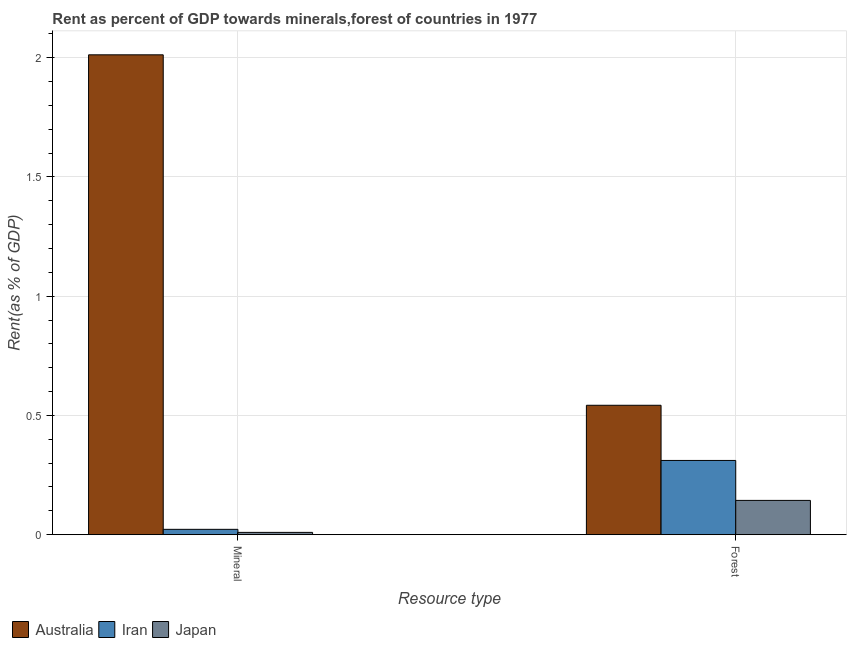How many different coloured bars are there?
Your answer should be very brief. 3. How many groups of bars are there?
Your answer should be compact. 2. Are the number of bars per tick equal to the number of legend labels?
Your answer should be very brief. Yes. How many bars are there on the 1st tick from the right?
Your answer should be compact. 3. What is the label of the 2nd group of bars from the left?
Ensure brevity in your answer.  Forest. What is the mineral rent in Japan?
Your response must be concise. 0.01. Across all countries, what is the maximum forest rent?
Offer a very short reply. 0.54. Across all countries, what is the minimum forest rent?
Provide a short and direct response. 0.14. In which country was the mineral rent maximum?
Make the answer very short. Australia. What is the total mineral rent in the graph?
Your response must be concise. 2.04. What is the difference between the mineral rent in Japan and that in Australia?
Your answer should be very brief. -2. What is the difference between the forest rent in Japan and the mineral rent in Australia?
Keep it short and to the point. -1.87. What is the average mineral rent per country?
Provide a succinct answer. 0.68. What is the difference between the mineral rent and forest rent in Iran?
Offer a very short reply. -0.29. What is the ratio of the mineral rent in Australia to that in Japan?
Your response must be concise. 207.4. Is the forest rent in Iran less than that in Japan?
Make the answer very short. No. In how many countries, is the mineral rent greater than the average mineral rent taken over all countries?
Ensure brevity in your answer.  1. What does the 2nd bar from the right in Mineral represents?
Provide a short and direct response. Iran. How many countries are there in the graph?
Provide a succinct answer. 3. What is the difference between two consecutive major ticks on the Y-axis?
Provide a succinct answer. 0.5. Does the graph contain any zero values?
Ensure brevity in your answer.  No. How are the legend labels stacked?
Ensure brevity in your answer.  Horizontal. What is the title of the graph?
Offer a very short reply. Rent as percent of GDP towards minerals,forest of countries in 1977. What is the label or title of the X-axis?
Provide a short and direct response. Resource type. What is the label or title of the Y-axis?
Your answer should be very brief. Rent(as % of GDP). What is the Rent(as % of GDP) in Australia in Mineral?
Your answer should be very brief. 2.01. What is the Rent(as % of GDP) of Iran in Mineral?
Give a very brief answer. 0.02. What is the Rent(as % of GDP) in Japan in Mineral?
Offer a very short reply. 0.01. What is the Rent(as % of GDP) in Australia in Forest?
Ensure brevity in your answer.  0.54. What is the Rent(as % of GDP) of Iran in Forest?
Give a very brief answer. 0.31. What is the Rent(as % of GDP) in Japan in Forest?
Offer a very short reply. 0.14. Across all Resource type, what is the maximum Rent(as % of GDP) of Australia?
Make the answer very short. 2.01. Across all Resource type, what is the maximum Rent(as % of GDP) of Iran?
Give a very brief answer. 0.31. Across all Resource type, what is the maximum Rent(as % of GDP) in Japan?
Your response must be concise. 0.14. Across all Resource type, what is the minimum Rent(as % of GDP) in Australia?
Make the answer very short. 0.54. Across all Resource type, what is the minimum Rent(as % of GDP) in Iran?
Make the answer very short. 0.02. Across all Resource type, what is the minimum Rent(as % of GDP) of Japan?
Provide a short and direct response. 0.01. What is the total Rent(as % of GDP) of Australia in the graph?
Offer a terse response. 2.55. What is the total Rent(as % of GDP) of Iran in the graph?
Make the answer very short. 0.33. What is the total Rent(as % of GDP) of Japan in the graph?
Give a very brief answer. 0.15. What is the difference between the Rent(as % of GDP) in Australia in Mineral and that in Forest?
Offer a very short reply. 1.47. What is the difference between the Rent(as % of GDP) in Iran in Mineral and that in Forest?
Keep it short and to the point. -0.29. What is the difference between the Rent(as % of GDP) of Japan in Mineral and that in Forest?
Make the answer very short. -0.13. What is the difference between the Rent(as % of GDP) of Australia in Mineral and the Rent(as % of GDP) of Iran in Forest?
Keep it short and to the point. 1.7. What is the difference between the Rent(as % of GDP) of Australia in Mineral and the Rent(as % of GDP) of Japan in Forest?
Keep it short and to the point. 1.87. What is the difference between the Rent(as % of GDP) of Iran in Mineral and the Rent(as % of GDP) of Japan in Forest?
Offer a terse response. -0.12. What is the average Rent(as % of GDP) of Australia per Resource type?
Give a very brief answer. 1.28. What is the average Rent(as % of GDP) of Iran per Resource type?
Make the answer very short. 0.17. What is the average Rent(as % of GDP) of Japan per Resource type?
Provide a short and direct response. 0.08. What is the difference between the Rent(as % of GDP) in Australia and Rent(as % of GDP) in Iran in Mineral?
Provide a succinct answer. 1.99. What is the difference between the Rent(as % of GDP) in Australia and Rent(as % of GDP) in Japan in Mineral?
Provide a succinct answer. 2. What is the difference between the Rent(as % of GDP) of Iran and Rent(as % of GDP) of Japan in Mineral?
Your answer should be compact. 0.01. What is the difference between the Rent(as % of GDP) of Australia and Rent(as % of GDP) of Iran in Forest?
Provide a short and direct response. 0.23. What is the difference between the Rent(as % of GDP) in Australia and Rent(as % of GDP) in Japan in Forest?
Your response must be concise. 0.4. What is the difference between the Rent(as % of GDP) in Iran and Rent(as % of GDP) in Japan in Forest?
Make the answer very short. 0.17. What is the ratio of the Rent(as % of GDP) in Australia in Mineral to that in Forest?
Provide a short and direct response. 3.71. What is the ratio of the Rent(as % of GDP) in Iran in Mineral to that in Forest?
Your answer should be very brief. 0.07. What is the ratio of the Rent(as % of GDP) of Japan in Mineral to that in Forest?
Keep it short and to the point. 0.07. What is the difference between the highest and the second highest Rent(as % of GDP) of Australia?
Give a very brief answer. 1.47. What is the difference between the highest and the second highest Rent(as % of GDP) of Iran?
Your answer should be compact. 0.29. What is the difference between the highest and the second highest Rent(as % of GDP) of Japan?
Make the answer very short. 0.13. What is the difference between the highest and the lowest Rent(as % of GDP) in Australia?
Provide a short and direct response. 1.47. What is the difference between the highest and the lowest Rent(as % of GDP) in Iran?
Offer a terse response. 0.29. What is the difference between the highest and the lowest Rent(as % of GDP) in Japan?
Your answer should be very brief. 0.13. 